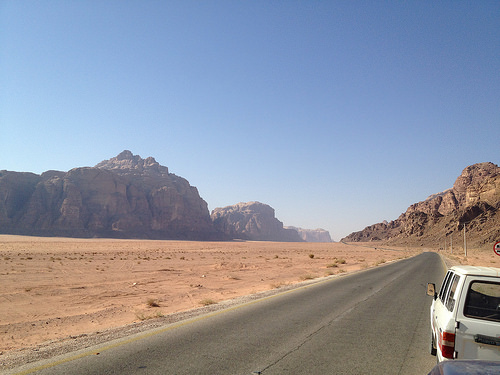<image>
Is there a road under the jeep? Yes. The road is positioned underneath the jeep, with the jeep above it in the vertical space. Is there a sky behind the mountain? Yes. From this viewpoint, the sky is positioned behind the mountain, with the mountain partially or fully occluding the sky. 